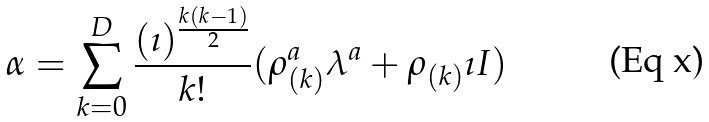<formula> <loc_0><loc_0><loc_500><loc_500>\alpha = \sum _ { k = 0 } ^ { D } { \frac { ( \imath ) ^ { \frac { k ( k - 1 ) } { 2 } } } { k ! } } ( \rho _ { ( k ) } ^ { a } \lambda ^ { a } + \rho _ { ( k ) } \imath I )</formula> 